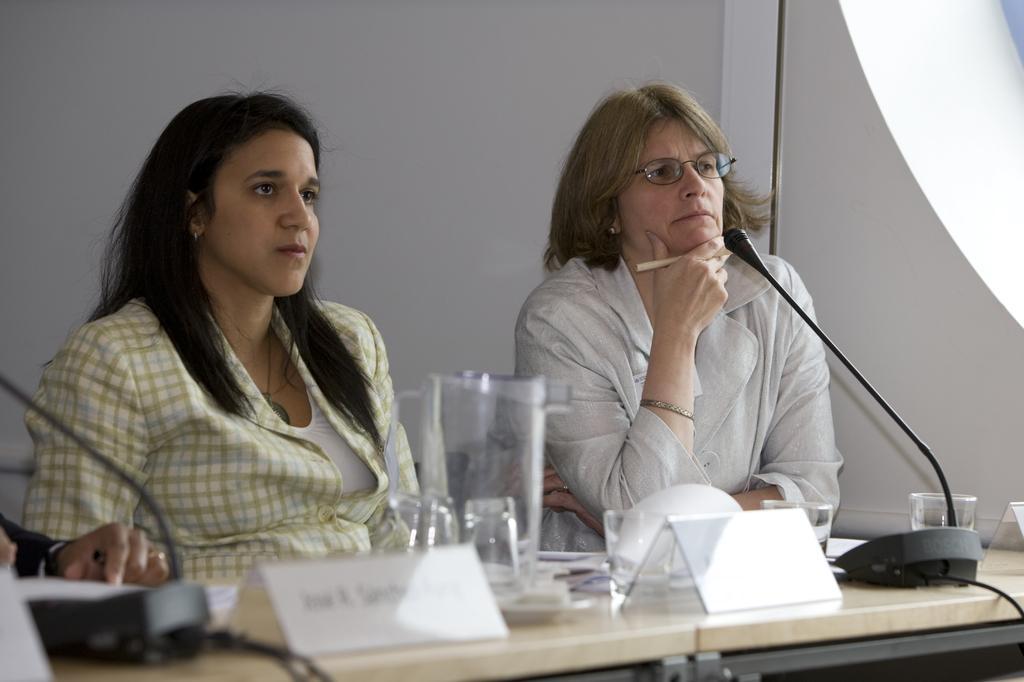Could you give a brief overview of what you see in this image? In this image, There is a table which is in white color on that table there are some glasses and a jug there are some white color objects, There is a microphone which is in black color, There are two women sitting on the chairs, In the background there is a white color wall. 